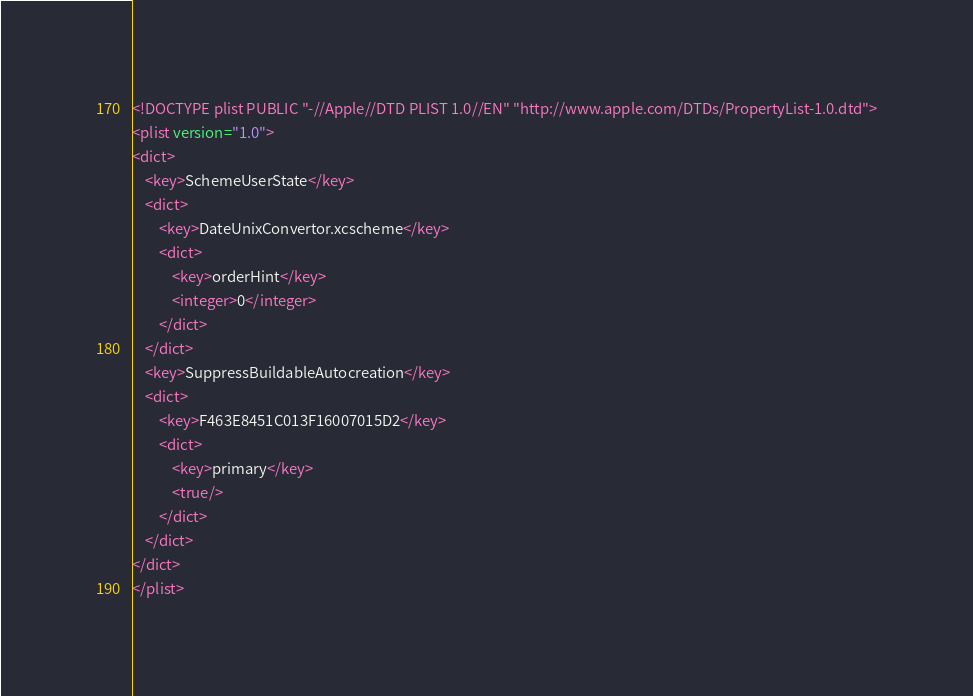Convert code to text. <code><loc_0><loc_0><loc_500><loc_500><_XML_><!DOCTYPE plist PUBLIC "-//Apple//DTD PLIST 1.0//EN" "http://www.apple.com/DTDs/PropertyList-1.0.dtd">
<plist version="1.0">
<dict>
	<key>SchemeUserState</key>
	<dict>
		<key>DateUnixConvertor.xcscheme</key>
		<dict>
			<key>orderHint</key>
			<integer>0</integer>
		</dict>
	</dict>
	<key>SuppressBuildableAutocreation</key>
	<dict>
		<key>F463E8451C013F16007015D2</key>
		<dict>
			<key>primary</key>
			<true/>
		</dict>
	</dict>
</dict>
</plist>
</code> 